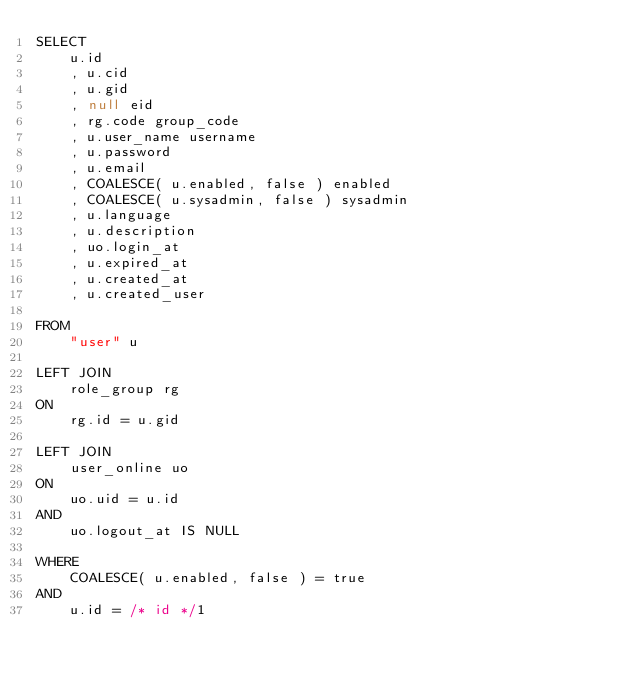Convert code to text. <code><loc_0><loc_0><loc_500><loc_500><_SQL_>SELECT
		u.id
		, u.cid
		, u.gid
		, null eid
		, rg.code group_code
		, u.user_name username
		, u.password
		, u.email
		, COALESCE( u.enabled, false ) enabled
		, COALESCE( u.sysadmin, false ) sysadmin
		, u.language
		, u.description
		, uo.login_at
		, u.expired_at
		, u.created_at
		, u.created_user

FROM
		"user" u

LEFT JOIN
		role_group rg
ON
		rg.id = u.gid

LEFT JOIN
		user_online uo
ON
		uo.uid = u.id
AND
		uo.logout_at IS NULL

WHERE
		COALESCE( u.enabled, false ) = true
AND
		u.id = /* id */1
</code> 